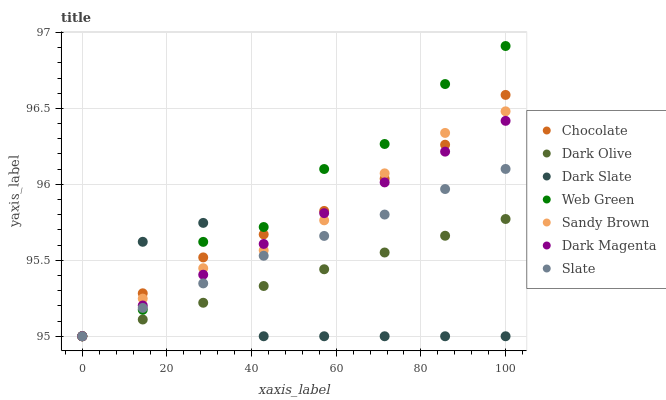Does Dark Slate have the minimum area under the curve?
Answer yes or no. Yes. Does Web Green have the maximum area under the curve?
Answer yes or no. Yes. Does Slate have the minimum area under the curve?
Answer yes or no. No. Does Slate have the maximum area under the curve?
Answer yes or no. No. Is Dark Olive the smoothest?
Answer yes or no. Yes. Is Dark Slate the roughest?
Answer yes or no. Yes. Is Slate the smoothest?
Answer yes or no. No. Is Slate the roughest?
Answer yes or no. No. Does Dark Magenta have the lowest value?
Answer yes or no. Yes. Does Web Green have the highest value?
Answer yes or no. Yes. Does Slate have the highest value?
Answer yes or no. No. Does Slate intersect Dark Magenta?
Answer yes or no. Yes. Is Slate less than Dark Magenta?
Answer yes or no. No. Is Slate greater than Dark Magenta?
Answer yes or no. No. 